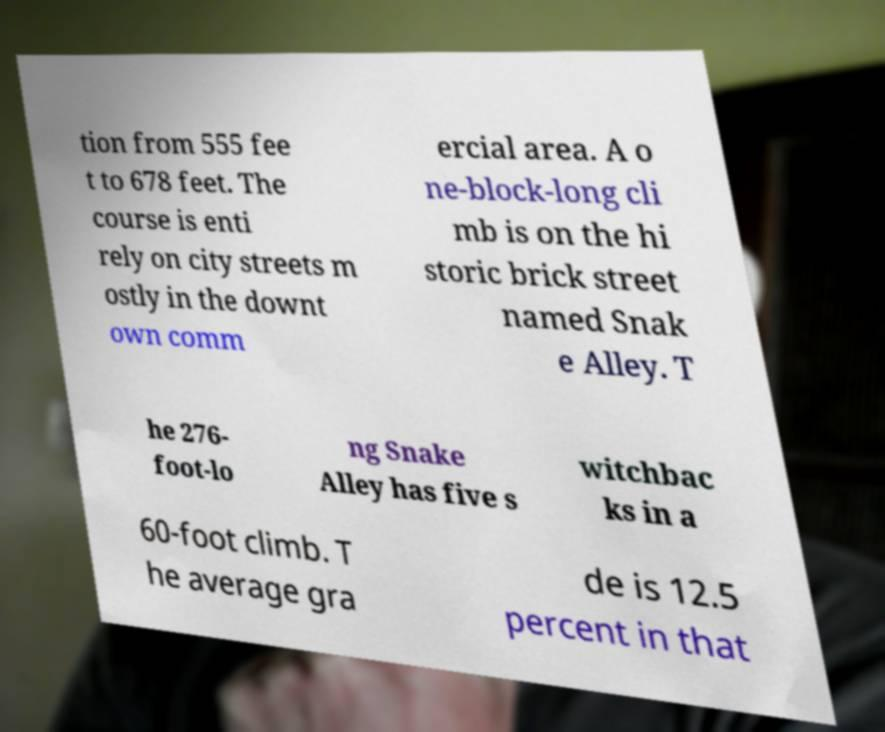Please identify and transcribe the text found in this image. tion from 555 fee t to 678 feet. The course is enti rely on city streets m ostly in the downt own comm ercial area. A o ne-block-long cli mb is on the hi storic brick street named Snak e Alley. T he 276- foot-lo ng Snake Alley has five s witchbac ks in a 60-foot climb. T he average gra de is 12.5 percent in that 